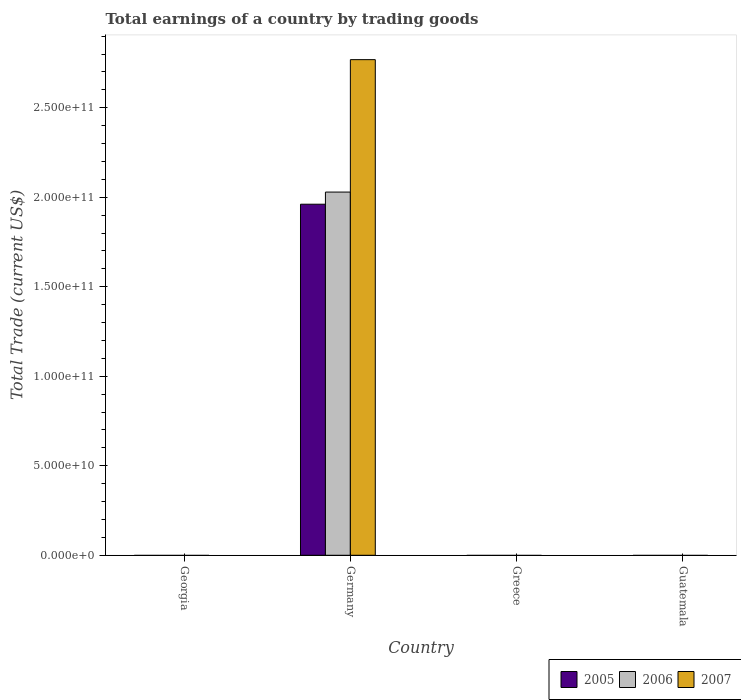Are the number of bars on each tick of the X-axis equal?
Offer a very short reply. No. How many bars are there on the 2nd tick from the right?
Make the answer very short. 0. In how many cases, is the number of bars for a given country not equal to the number of legend labels?
Your response must be concise. 3. What is the total earnings in 2005 in Greece?
Provide a succinct answer. 0. Across all countries, what is the maximum total earnings in 2006?
Your answer should be compact. 2.03e+11. What is the total total earnings in 2007 in the graph?
Keep it short and to the point. 2.77e+11. What is the average total earnings in 2005 per country?
Make the answer very short. 4.90e+1. What is the difference between the total earnings of/in 2007 and total earnings of/in 2006 in Germany?
Your answer should be compact. 7.40e+1. What is the difference between the highest and the lowest total earnings in 2006?
Ensure brevity in your answer.  2.03e+11. In how many countries, is the total earnings in 2007 greater than the average total earnings in 2007 taken over all countries?
Ensure brevity in your answer.  1. How many bars are there?
Keep it short and to the point. 3. How many countries are there in the graph?
Provide a short and direct response. 4. Are the values on the major ticks of Y-axis written in scientific E-notation?
Provide a succinct answer. Yes. Does the graph contain any zero values?
Provide a succinct answer. Yes. Does the graph contain grids?
Offer a terse response. No. How are the legend labels stacked?
Offer a terse response. Horizontal. What is the title of the graph?
Your response must be concise. Total earnings of a country by trading goods. Does "2002" appear as one of the legend labels in the graph?
Your answer should be very brief. No. What is the label or title of the X-axis?
Provide a short and direct response. Country. What is the label or title of the Y-axis?
Keep it short and to the point. Total Trade (current US$). What is the Total Trade (current US$) in 2006 in Georgia?
Your response must be concise. 0. What is the Total Trade (current US$) in 2005 in Germany?
Give a very brief answer. 1.96e+11. What is the Total Trade (current US$) of 2006 in Germany?
Keep it short and to the point. 2.03e+11. What is the Total Trade (current US$) of 2007 in Germany?
Provide a succinct answer. 2.77e+11. What is the Total Trade (current US$) of 2005 in Guatemala?
Keep it short and to the point. 0. Across all countries, what is the maximum Total Trade (current US$) in 2005?
Make the answer very short. 1.96e+11. Across all countries, what is the maximum Total Trade (current US$) of 2006?
Keep it short and to the point. 2.03e+11. Across all countries, what is the maximum Total Trade (current US$) of 2007?
Your response must be concise. 2.77e+11. Across all countries, what is the minimum Total Trade (current US$) in 2005?
Offer a very short reply. 0. Across all countries, what is the minimum Total Trade (current US$) of 2006?
Ensure brevity in your answer.  0. What is the total Total Trade (current US$) of 2005 in the graph?
Offer a very short reply. 1.96e+11. What is the total Total Trade (current US$) of 2006 in the graph?
Ensure brevity in your answer.  2.03e+11. What is the total Total Trade (current US$) in 2007 in the graph?
Offer a very short reply. 2.77e+11. What is the average Total Trade (current US$) of 2005 per country?
Ensure brevity in your answer.  4.90e+1. What is the average Total Trade (current US$) in 2006 per country?
Offer a terse response. 5.07e+1. What is the average Total Trade (current US$) of 2007 per country?
Offer a terse response. 6.92e+1. What is the difference between the Total Trade (current US$) of 2005 and Total Trade (current US$) of 2006 in Germany?
Ensure brevity in your answer.  -6.78e+09. What is the difference between the Total Trade (current US$) of 2005 and Total Trade (current US$) of 2007 in Germany?
Offer a terse response. -8.08e+1. What is the difference between the Total Trade (current US$) of 2006 and Total Trade (current US$) of 2007 in Germany?
Offer a very short reply. -7.40e+1. What is the difference between the highest and the lowest Total Trade (current US$) of 2005?
Offer a very short reply. 1.96e+11. What is the difference between the highest and the lowest Total Trade (current US$) of 2006?
Offer a very short reply. 2.03e+11. What is the difference between the highest and the lowest Total Trade (current US$) in 2007?
Your response must be concise. 2.77e+11. 